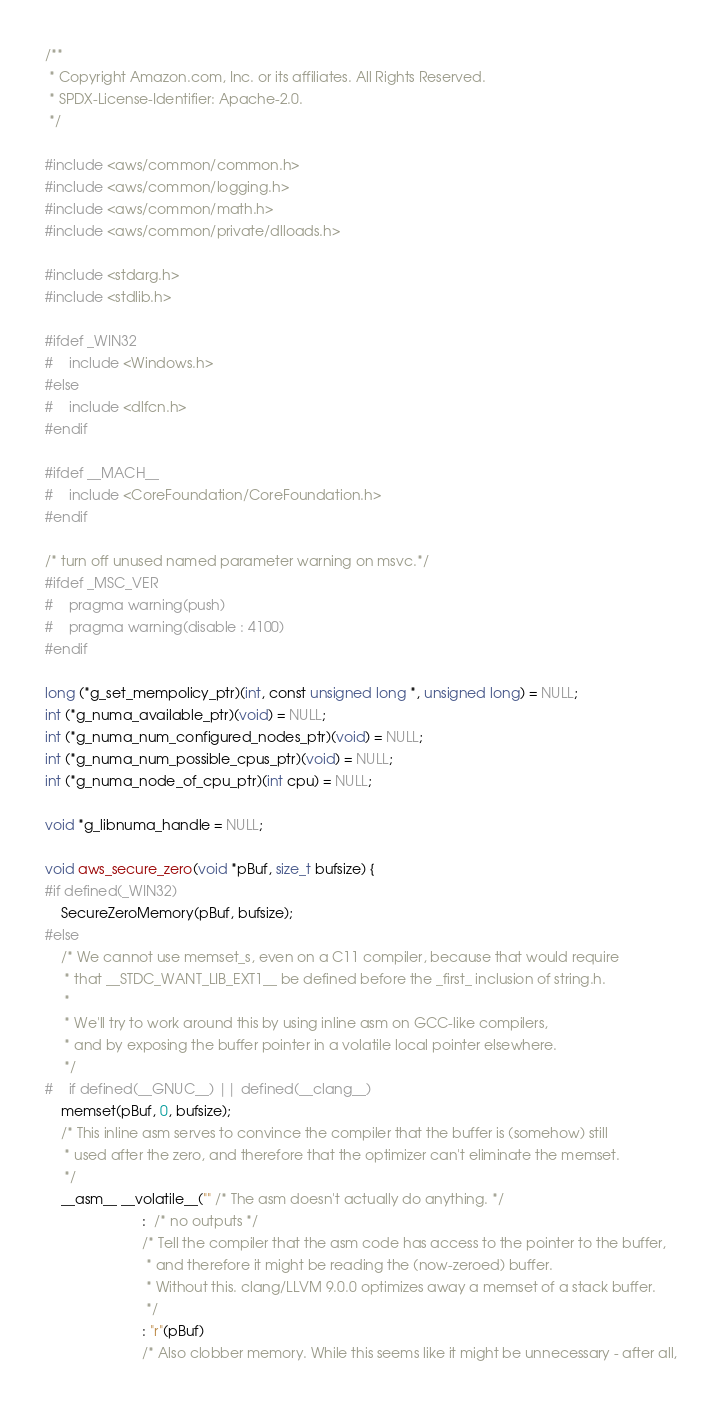Convert code to text. <code><loc_0><loc_0><loc_500><loc_500><_C_>/**
 * Copyright Amazon.com, Inc. or its affiliates. All Rights Reserved.
 * SPDX-License-Identifier: Apache-2.0.
 */

#include <aws/common/common.h>
#include <aws/common/logging.h>
#include <aws/common/math.h>
#include <aws/common/private/dlloads.h>

#include <stdarg.h>
#include <stdlib.h>

#ifdef _WIN32
#    include <Windows.h>
#else
#    include <dlfcn.h>
#endif

#ifdef __MACH__
#    include <CoreFoundation/CoreFoundation.h>
#endif

/* turn off unused named parameter warning on msvc.*/
#ifdef _MSC_VER
#    pragma warning(push)
#    pragma warning(disable : 4100)
#endif

long (*g_set_mempolicy_ptr)(int, const unsigned long *, unsigned long) = NULL;
int (*g_numa_available_ptr)(void) = NULL;
int (*g_numa_num_configured_nodes_ptr)(void) = NULL;
int (*g_numa_num_possible_cpus_ptr)(void) = NULL;
int (*g_numa_node_of_cpu_ptr)(int cpu) = NULL;

void *g_libnuma_handle = NULL;

void aws_secure_zero(void *pBuf, size_t bufsize) {
#if defined(_WIN32)
    SecureZeroMemory(pBuf, bufsize);
#else
    /* We cannot use memset_s, even on a C11 compiler, because that would require
     * that __STDC_WANT_LIB_EXT1__ be defined before the _first_ inclusion of string.h.
     *
     * We'll try to work around this by using inline asm on GCC-like compilers,
     * and by exposing the buffer pointer in a volatile local pointer elsewhere.
     */
#    if defined(__GNUC__) || defined(__clang__)
    memset(pBuf, 0, bufsize);
    /* This inline asm serves to convince the compiler that the buffer is (somehow) still
     * used after the zero, and therefore that the optimizer can't eliminate the memset.
     */
    __asm__ __volatile__("" /* The asm doesn't actually do anything. */
                         :  /* no outputs */
                         /* Tell the compiler that the asm code has access to the pointer to the buffer,
                          * and therefore it might be reading the (now-zeroed) buffer.
                          * Without this. clang/LLVM 9.0.0 optimizes away a memset of a stack buffer.
                          */
                         : "r"(pBuf)
                         /* Also clobber memory. While this seems like it might be unnecessary - after all,</code> 